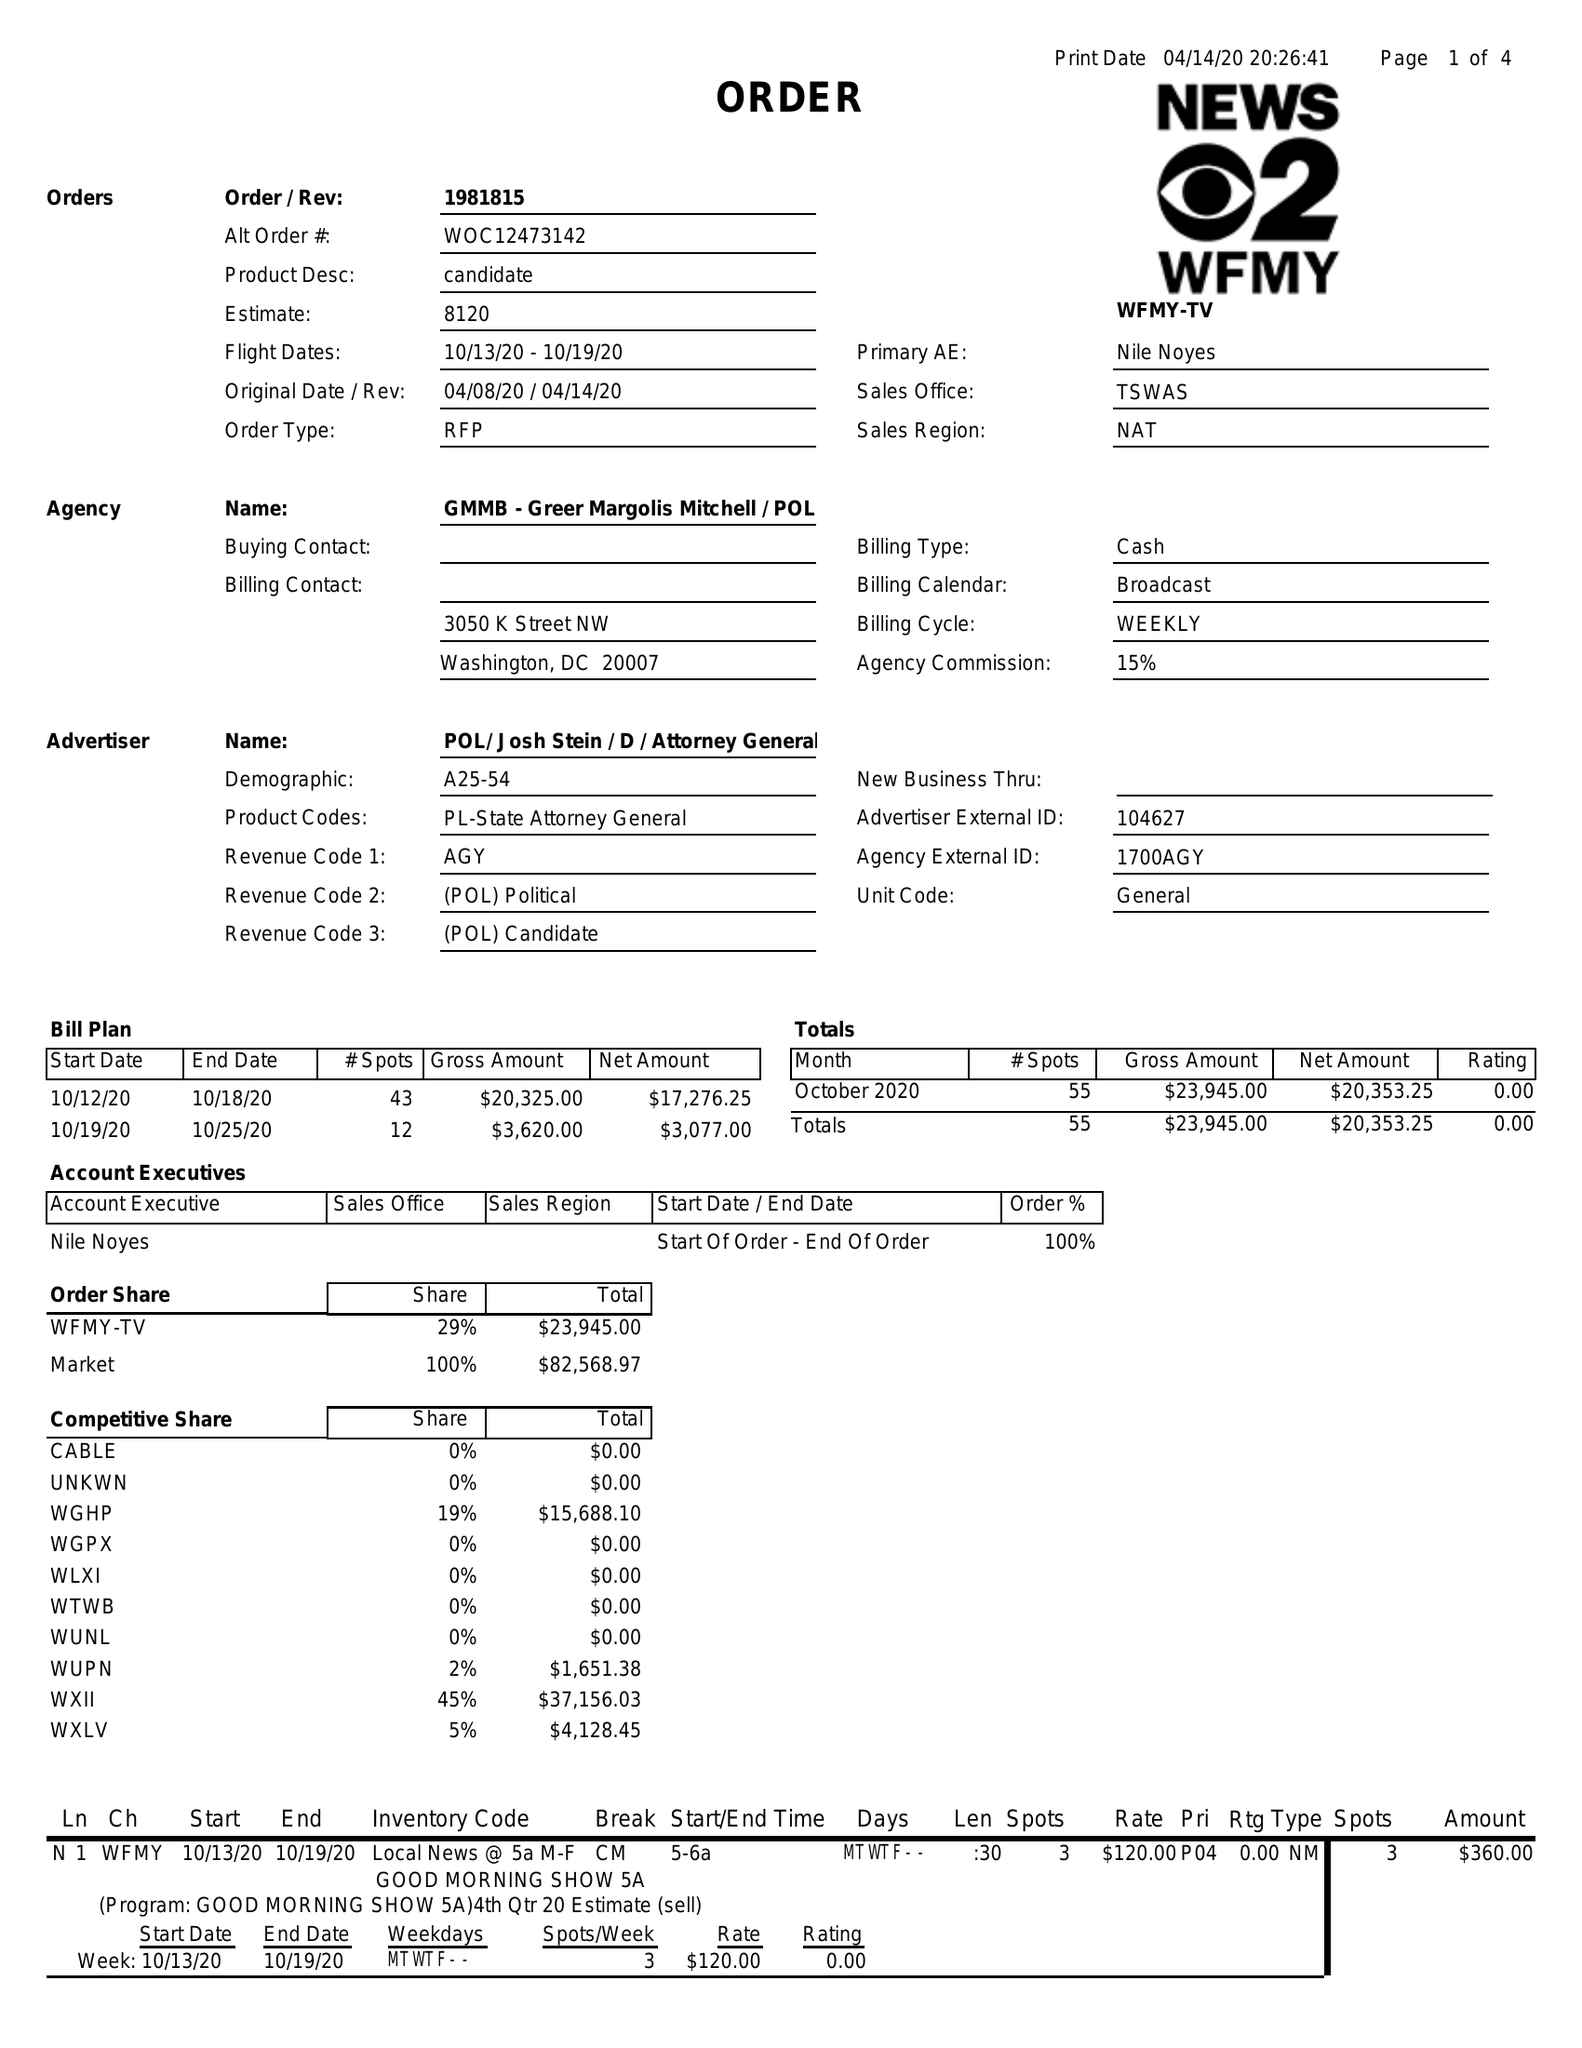What is the value for the flight_to?
Answer the question using a single word or phrase. 10/19/20 